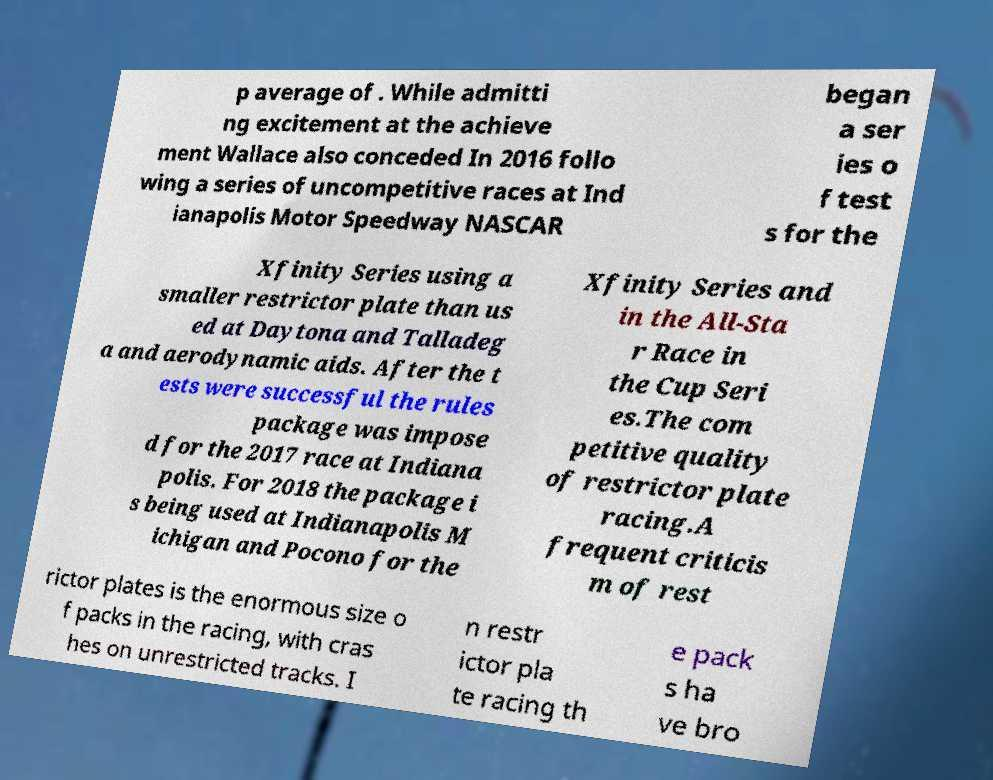There's text embedded in this image that I need extracted. Can you transcribe it verbatim? p average of . While admitti ng excitement at the achieve ment Wallace also conceded In 2016 follo wing a series of uncompetitive races at Ind ianapolis Motor Speedway NASCAR began a ser ies o f test s for the Xfinity Series using a smaller restrictor plate than us ed at Daytona and Talladeg a and aerodynamic aids. After the t ests were successful the rules package was impose d for the 2017 race at Indiana polis. For 2018 the package i s being used at Indianapolis M ichigan and Pocono for the Xfinity Series and in the All-Sta r Race in the Cup Seri es.The com petitive quality of restrictor plate racing.A frequent criticis m of rest rictor plates is the enormous size o f packs in the racing, with cras hes on unrestricted tracks. I n restr ictor pla te racing th e pack s ha ve bro 